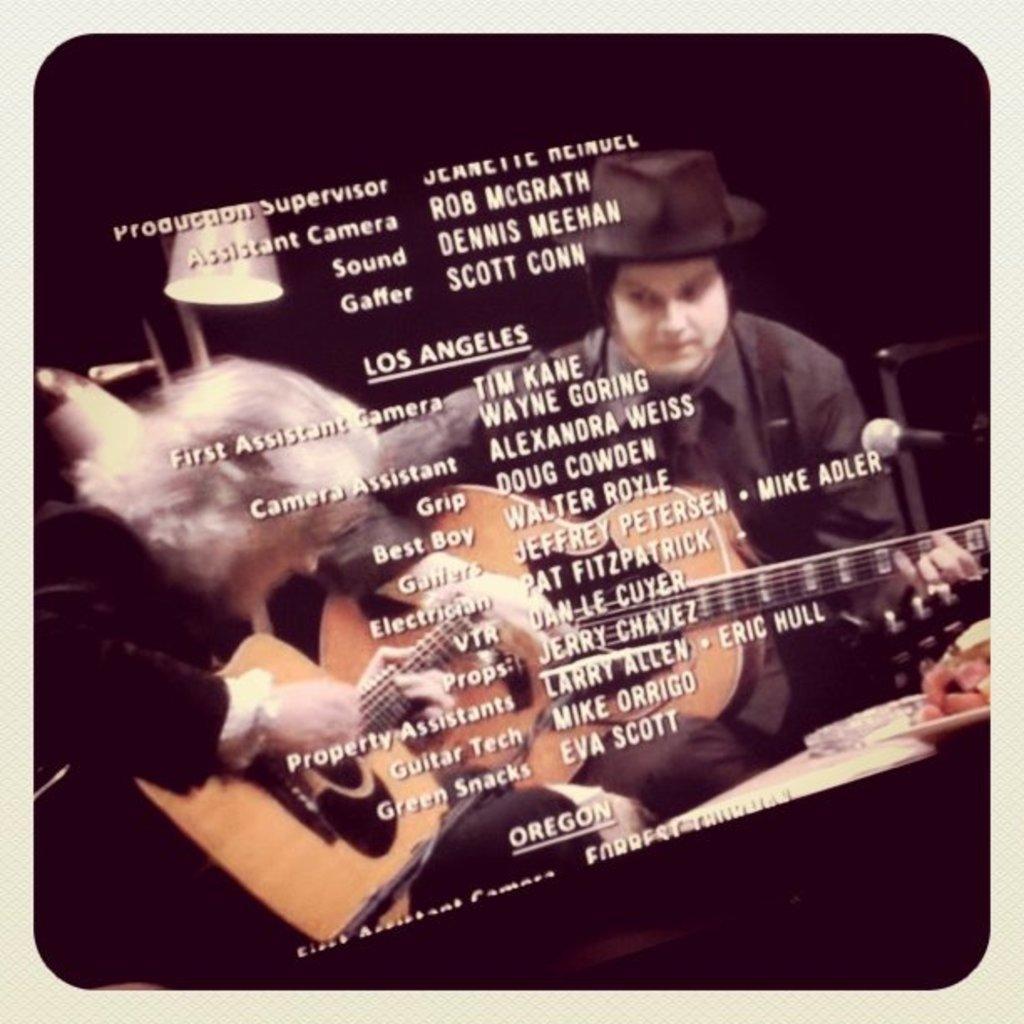Please provide a concise description of this image. In this picture we can see two persons playing guitars, a person on the right side wore a cap, we can see a microphone here, in the background there is a lamp, we can see some text here. 